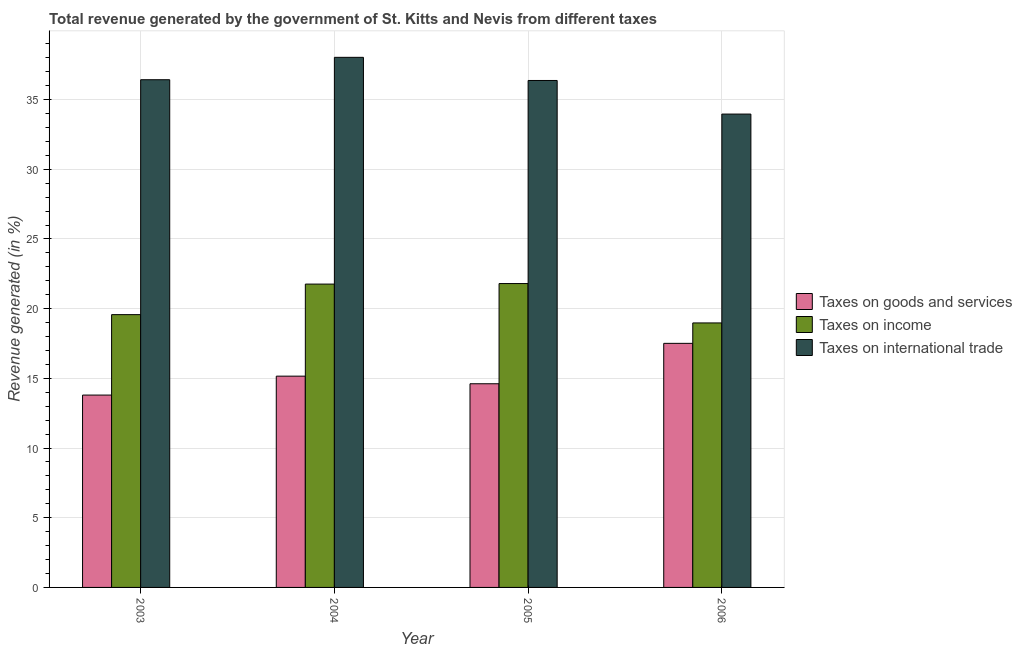How many different coloured bars are there?
Keep it short and to the point. 3. Are the number of bars per tick equal to the number of legend labels?
Make the answer very short. Yes. How many bars are there on the 4th tick from the right?
Keep it short and to the point. 3. What is the label of the 3rd group of bars from the left?
Your answer should be compact. 2005. In how many cases, is the number of bars for a given year not equal to the number of legend labels?
Keep it short and to the point. 0. What is the percentage of revenue generated by taxes on income in 2005?
Provide a short and direct response. 21.8. Across all years, what is the maximum percentage of revenue generated by taxes on goods and services?
Provide a succinct answer. 17.51. Across all years, what is the minimum percentage of revenue generated by taxes on goods and services?
Provide a succinct answer. 13.8. In which year was the percentage of revenue generated by taxes on goods and services maximum?
Your response must be concise. 2006. What is the total percentage of revenue generated by taxes on income in the graph?
Your answer should be very brief. 82.12. What is the difference between the percentage of revenue generated by taxes on goods and services in 2005 and that in 2006?
Make the answer very short. -2.9. What is the difference between the percentage of revenue generated by tax on international trade in 2004 and the percentage of revenue generated by taxes on income in 2005?
Make the answer very short. 1.66. What is the average percentage of revenue generated by tax on international trade per year?
Make the answer very short. 36.2. What is the ratio of the percentage of revenue generated by taxes on income in 2003 to that in 2005?
Offer a very short reply. 0.9. Is the percentage of revenue generated by tax on international trade in 2004 less than that in 2006?
Provide a succinct answer. No. What is the difference between the highest and the second highest percentage of revenue generated by tax on international trade?
Your response must be concise. 1.61. What is the difference between the highest and the lowest percentage of revenue generated by tax on international trade?
Make the answer very short. 4.07. In how many years, is the percentage of revenue generated by taxes on goods and services greater than the average percentage of revenue generated by taxes on goods and services taken over all years?
Your answer should be compact. 1. Is the sum of the percentage of revenue generated by tax on international trade in 2004 and 2005 greater than the maximum percentage of revenue generated by taxes on income across all years?
Your answer should be compact. Yes. What does the 2nd bar from the left in 2004 represents?
Offer a terse response. Taxes on income. What does the 3rd bar from the right in 2003 represents?
Keep it short and to the point. Taxes on goods and services. How many bars are there?
Your answer should be compact. 12. Are all the bars in the graph horizontal?
Offer a terse response. No. What is the difference between two consecutive major ticks on the Y-axis?
Keep it short and to the point. 5. Are the values on the major ticks of Y-axis written in scientific E-notation?
Offer a terse response. No. Does the graph contain grids?
Provide a short and direct response. Yes. Where does the legend appear in the graph?
Make the answer very short. Center right. How many legend labels are there?
Provide a short and direct response. 3. What is the title of the graph?
Your answer should be compact. Total revenue generated by the government of St. Kitts and Nevis from different taxes. Does "ICT services" appear as one of the legend labels in the graph?
Keep it short and to the point. No. What is the label or title of the X-axis?
Give a very brief answer. Year. What is the label or title of the Y-axis?
Provide a succinct answer. Revenue generated (in %). What is the Revenue generated (in %) in Taxes on goods and services in 2003?
Your answer should be compact. 13.8. What is the Revenue generated (in %) of Taxes on income in 2003?
Your answer should be very brief. 19.57. What is the Revenue generated (in %) of Taxes on international trade in 2003?
Make the answer very short. 36.43. What is the Revenue generated (in %) of Taxes on goods and services in 2004?
Offer a very short reply. 15.16. What is the Revenue generated (in %) in Taxes on income in 2004?
Make the answer very short. 21.77. What is the Revenue generated (in %) of Taxes on international trade in 2004?
Your answer should be compact. 38.03. What is the Revenue generated (in %) in Taxes on goods and services in 2005?
Your answer should be very brief. 14.61. What is the Revenue generated (in %) in Taxes on income in 2005?
Make the answer very short. 21.8. What is the Revenue generated (in %) in Taxes on international trade in 2005?
Offer a terse response. 36.37. What is the Revenue generated (in %) in Taxes on goods and services in 2006?
Your response must be concise. 17.51. What is the Revenue generated (in %) of Taxes on income in 2006?
Your answer should be very brief. 18.98. What is the Revenue generated (in %) of Taxes on international trade in 2006?
Give a very brief answer. 33.96. Across all years, what is the maximum Revenue generated (in %) in Taxes on goods and services?
Give a very brief answer. 17.51. Across all years, what is the maximum Revenue generated (in %) in Taxes on income?
Your answer should be very brief. 21.8. Across all years, what is the maximum Revenue generated (in %) of Taxes on international trade?
Your answer should be very brief. 38.03. Across all years, what is the minimum Revenue generated (in %) of Taxes on goods and services?
Your answer should be very brief. 13.8. Across all years, what is the minimum Revenue generated (in %) in Taxes on income?
Your response must be concise. 18.98. Across all years, what is the minimum Revenue generated (in %) of Taxes on international trade?
Your answer should be compact. 33.96. What is the total Revenue generated (in %) in Taxes on goods and services in the graph?
Offer a terse response. 61.09. What is the total Revenue generated (in %) in Taxes on income in the graph?
Provide a short and direct response. 82.12. What is the total Revenue generated (in %) of Taxes on international trade in the graph?
Offer a terse response. 144.8. What is the difference between the Revenue generated (in %) in Taxes on goods and services in 2003 and that in 2004?
Offer a very short reply. -1.36. What is the difference between the Revenue generated (in %) of Taxes on income in 2003 and that in 2004?
Keep it short and to the point. -2.19. What is the difference between the Revenue generated (in %) of Taxes on international trade in 2003 and that in 2004?
Give a very brief answer. -1.61. What is the difference between the Revenue generated (in %) in Taxes on goods and services in 2003 and that in 2005?
Ensure brevity in your answer.  -0.81. What is the difference between the Revenue generated (in %) in Taxes on income in 2003 and that in 2005?
Keep it short and to the point. -2.23. What is the difference between the Revenue generated (in %) in Taxes on international trade in 2003 and that in 2005?
Provide a succinct answer. 0.05. What is the difference between the Revenue generated (in %) in Taxes on goods and services in 2003 and that in 2006?
Your answer should be compact. -3.71. What is the difference between the Revenue generated (in %) in Taxes on income in 2003 and that in 2006?
Provide a short and direct response. 0.59. What is the difference between the Revenue generated (in %) of Taxes on international trade in 2003 and that in 2006?
Your response must be concise. 2.46. What is the difference between the Revenue generated (in %) in Taxes on goods and services in 2004 and that in 2005?
Provide a short and direct response. 0.55. What is the difference between the Revenue generated (in %) in Taxes on income in 2004 and that in 2005?
Your answer should be compact. -0.04. What is the difference between the Revenue generated (in %) in Taxes on international trade in 2004 and that in 2005?
Offer a very short reply. 1.66. What is the difference between the Revenue generated (in %) of Taxes on goods and services in 2004 and that in 2006?
Keep it short and to the point. -2.35. What is the difference between the Revenue generated (in %) in Taxes on income in 2004 and that in 2006?
Make the answer very short. 2.79. What is the difference between the Revenue generated (in %) of Taxes on international trade in 2004 and that in 2006?
Provide a succinct answer. 4.07. What is the difference between the Revenue generated (in %) of Taxes on goods and services in 2005 and that in 2006?
Provide a short and direct response. -2.9. What is the difference between the Revenue generated (in %) of Taxes on income in 2005 and that in 2006?
Your answer should be very brief. 2.82. What is the difference between the Revenue generated (in %) in Taxes on international trade in 2005 and that in 2006?
Give a very brief answer. 2.41. What is the difference between the Revenue generated (in %) of Taxes on goods and services in 2003 and the Revenue generated (in %) of Taxes on income in 2004?
Your response must be concise. -7.96. What is the difference between the Revenue generated (in %) of Taxes on goods and services in 2003 and the Revenue generated (in %) of Taxes on international trade in 2004?
Make the answer very short. -24.23. What is the difference between the Revenue generated (in %) of Taxes on income in 2003 and the Revenue generated (in %) of Taxes on international trade in 2004?
Your answer should be very brief. -18.46. What is the difference between the Revenue generated (in %) in Taxes on goods and services in 2003 and the Revenue generated (in %) in Taxes on income in 2005?
Make the answer very short. -8. What is the difference between the Revenue generated (in %) in Taxes on goods and services in 2003 and the Revenue generated (in %) in Taxes on international trade in 2005?
Keep it short and to the point. -22.57. What is the difference between the Revenue generated (in %) in Taxes on income in 2003 and the Revenue generated (in %) in Taxes on international trade in 2005?
Provide a succinct answer. -16.8. What is the difference between the Revenue generated (in %) of Taxes on goods and services in 2003 and the Revenue generated (in %) of Taxes on income in 2006?
Ensure brevity in your answer.  -5.18. What is the difference between the Revenue generated (in %) in Taxes on goods and services in 2003 and the Revenue generated (in %) in Taxes on international trade in 2006?
Your answer should be compact. -20.16. What is the difference between the Revenue generated (in %) in Taxes on income in 2003 and the Revenue generated (in %) in Taxes on international trade in 2006?
Your response must be concise. -14.39. What is the difference between the Revenue generated (in %) in Taxes on goods and services in 2004 and the Revenue generated (in %) in Taxes on income in 2005?
Offer a terse response. -6.64. What is the difference between the Revenue generated (in %) of Taxes on goods and services in 2004 and the Revenue generated (in %) of Taxes on international trade in 2005?
Your response must be concise. -21.21. What is the difference between the Revenue generated (in %) in Taxes on income in 2004 and the Revenue generated (in %) in Taxes on international trade in 2005?
Offer a very short reply. -14.61. What is the difference between the Revenue generated (in %) in Taxes on goods and services in 2004 and the Revenue generated (in %) in Taxes on income in 2006?
Provide a short and direct response. -3.82. What is the difference between the Revenue generated (in %) of Taxes on goods and services in 2004 and the Revenue generated (in %) of Taxes on international trade in 2006?
Offer a terse response. -18.8. What is the difference between the Revenue generated (in %) in Taxes on income in 2004 and the Revenue generated (in %) in Taxes on international trade in 2006?
Your response must be concise. -12.2. What is the difference between the Revenue generated (in %) of Taxes on goods and services in 2005 and the Revenue generated (in %) of Taxes on income in 2006?
Provide a short and direct response. -4.36. What is the difference between the Revenue generated (in %) of Taxes on goods and services in 2005 and the Revenue generated (in %) of Taxes on international trade in 2006?
Offer a very short reply. -19.35. What is the difference between the Revenue generated (in %) of Taxes on income in 2005 and the Revenue generated (in %) of Taxes on international trade in 2006?
Keep it short and to the point. -12.16. What is the average Revenue generated (in %) in Taxes on goods and services per year?
Your answer should be compact. 15.27. What is the average Revenue generated (in %) in Taxes on income per year?
Your response must be concise. 20.53. What is the average Revenue generated (in %) in Taxes on international trade per year?
Your answer should be very brief. 36.2. In the year 2003, what is the difference between the Revenue generated (in %) in Taxes on goods and services and Revenue generated (in %) in Taxes on income?
Offer a very short reply. -5.77. In the year 2003, what is the difference between the Revenue generated (in %) of Taxes on goods and services and Revenue generated (in %) of Taxes on international trade?
Offer a very short reply. -22.63. In the year 2003, what is the difference between the Revenue generated (in %) of Taxes on income and Revenue generated (in %) of Taxes on international trade?
Your answer should be compact. -16.86. In the year 2004, what is the difference between the Revenue generated (in %) of Taxes on goods and services and Revenue generated (in %) of Taxes on income?
Your answer should be very brief. -6.61. In the year 2004, what is the difference between the Revenue generated (in %) of Taxes on goods and services and Revenue generated (in %) of Taxes on international trade?
Provide a short and direct response. -22.87. In the year 2004, what is the difference between the Revenue generated (in %) in Taxes on income and Revenue generated (in %) in Taxes on international trade?
Keep it short and to the point. -16.27. In the year 2005, what is the difference between the Revenue generated (in %) of Taxes on goods and services and Revenue generated (in %) of Taxes on income?
Provide a short and direct response. -7.19. In the year 2005, what is the difference between the Revenue generated (in %) of Taxes on goods and services and Revenue generated (in %) of Taxes on international trade?
Provide a succinct answer. -21.76. In the year 2005, what is the difference between the Revenue generated (in %) of Taxes on income and Revenue generated (in %) of Taxes on international trade?
Your answer should be very brief. -14.57. In the year 2006, what is the difference between the Revenue generated (in %) of Taxes on goods and services and Revenue generated (in %) of Taxes on income?
Keep it short and to the point. -1.47. In the year 2006, what is the difference between the Revenue generated (in %) of Taxes on goods and services and Revenue generated (in %) of Taxes on international trade?
Make the answer very short. -16.45. In the year 2006, what is the difference between the Revenue generated (in %) of Taxes on income and Revenue generated (in %) of Taxes on international trade?
Provide a short and direct response. -14.99. What is the ratio of the Revenue generated (in %) in Taxes on goods and services in 2003 to that in 2004?
Offer a terse response. 0.91. What is the ratio of the Revenue generated (in %) of Taxes on income in 2003 to that in 2004?
Provide a short and direct response. 0.9. What is the ratio of the Revenue generated (in %) in Taxes on international trade in 2003 to that in 2004?
Your answer should be compact. 0.96. What is the ratio of the Revenue generated (in %) in Taxes on goods and services in 2003 to that in 2005?
Offer a very short reply. 0.94. What is the ratio of the Revenue generated (in %) of Taxes on income in 2003 to that in 2005?
Your response must be concise. 0.9. What is the ratio of the Revenue generated (in %) in Taxes on goods and services in 2003 to that in 2006?
Provide a succinct answer. 0.79. What is the ratio of the Revenue generated (in %) of Taxes on income in 2003 to that in 2006?
Your answer should be compact. 1.03. What is the ratio of the Revenue generated (in %) in Taxes on international trade in 2003 to that in 2006?
Your answer should be very brief. 1.07. What is the ratio of the Revenue generated (in %) in Taxes on goods and services in 2004 to that in 2005?
Give a very brief answer. 1.04. What is the ratio of the Revenue generated (in %) of Taxes on international trade in 2004 to that in 2005?
Give a very brief answer. 1.05. What is the ratio of the Revenue generated (in %) of Taxes on goods and services in 2004 to that in 2006?
Give a very brief answer. 0.87. What is the ratio of the Revenue generated (in %) of Taxes on income in 2004 to that in 2006?
Ensure brevity in your answer.  1.15. What is the ratio of the Revenue generated (in %) of Taxes on international trade in 2004 to that in 2006?
Make the answer very short. 1.12. What is the ratio of the Revenue generated (in %) of Taxes on goods and services in 2005 to that in 2006?
Your answer should be compact. 0.83. What is the ratio of the Revenue generated (in %) in Taxes on income in 2005 to that in 2006?
Make the answer very short. 1.15. What is the ratio of the Revenue generated (in %) of Taxes on international trade in 2005 to that in 2006?
Provide a short and direct response. 1.07. What is the difference between the highest and the second highest Revenue generated (in %) of Taxes on goods and services?
Your answer should be compact. 2.35. What is the difference between the highest and the second highest Revenue generated (in %) of Taxes on income?
Give a very brief answer. 0.04. What is the difference between the highest and the second highest Revenue generated (in %) of Taxes on international trade?
Ensure brevity in your answer.  1.61. What is the difference between the highest and the lowest Revenue generated (in %) of Taxes on goods and services?
Ensure brevity in your answer.  3.71. What is the difference between the highest and the lowest Revenue generated (in %) in Taxes on income?
Give a very brief answer. 2.82. What is the difference between the highest and the lowest Revenue generated (in %) of Taxes on international trade?
Make the answer very short. 4.07. 